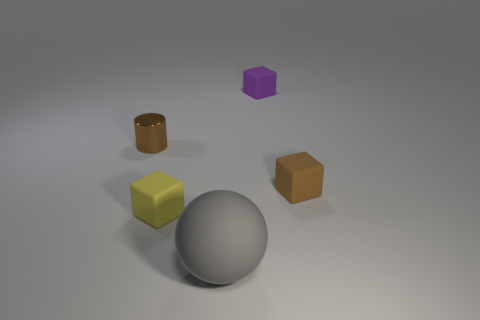There is a object that is the same color as the small metallic cylinder; what material is it?
Your answer should be very brief. Rubber. Are there any other things that have the same shape as the tiny metallic thing?
Provide a succinct answer. No. Is there any other thing that is the same size as the gray matte sphere?
Keep it short and to the point. No. There is a thing that is behind the small brown thing that is to the left of the tiny yellow cube; what is its shape?
Ensure brevity in your answer.  Cube. Are there fewer purple cubes to the right of the tiny purple rubber block than purple objects that are behind the tiny brown cylinder?
Your answer should be compact. Yes. How many cubes are right of the small yellow rubber cube and to the left of the tiny brown cube?
Your answer should be very brief. 1. Is the number of things behind the small brown cube greater than the number of tiny cubes that are on the left side of the purple matte object?
Offer a very short reply. Yes. The gray matte ball is what size?
Ensure brevity in your answer.  Large. Are there any tiny purple objects of the same shape as the brown rubber object?
Provide a succinct answer. Yes. Does the large gray object have the same shape as the tiny brown thing that is left of the small yellow cube?
Make the answer very short. No. 